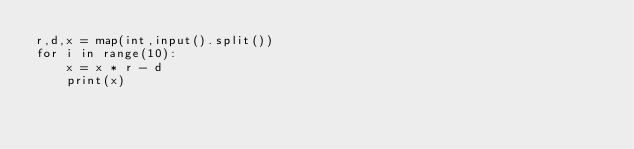<code> <loc_0><loc_0><loc_500><loc_500><_Python_>r,d,x = map(int,input().split())
for i in range(10):
    x = x * r - d
    print(x)</code> 